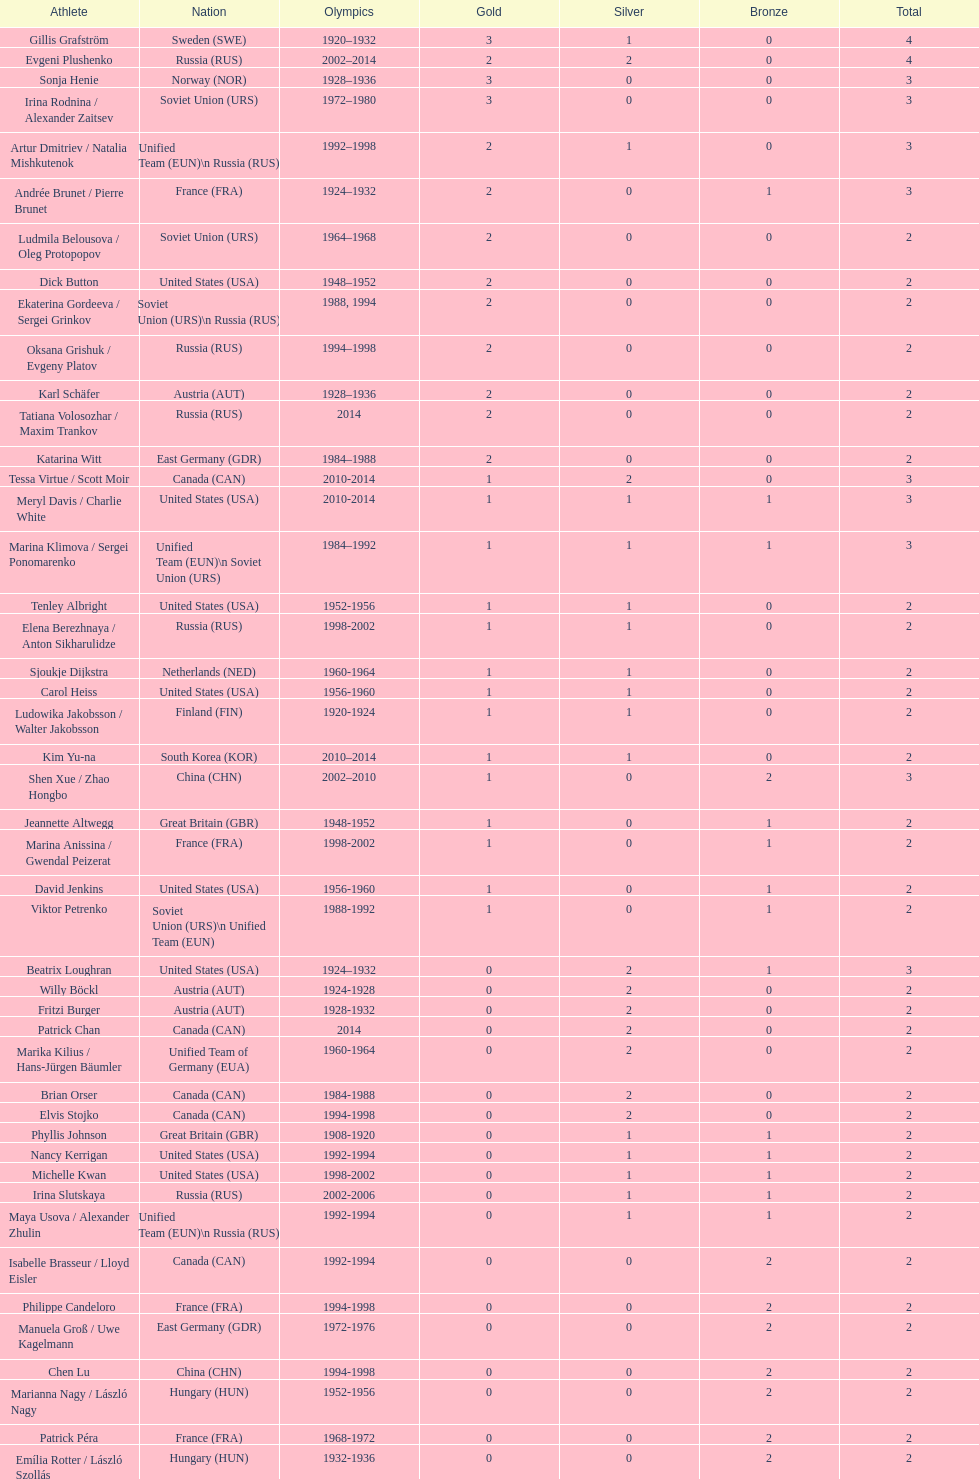How many silver medals has evgeni plushenko won? 2. 